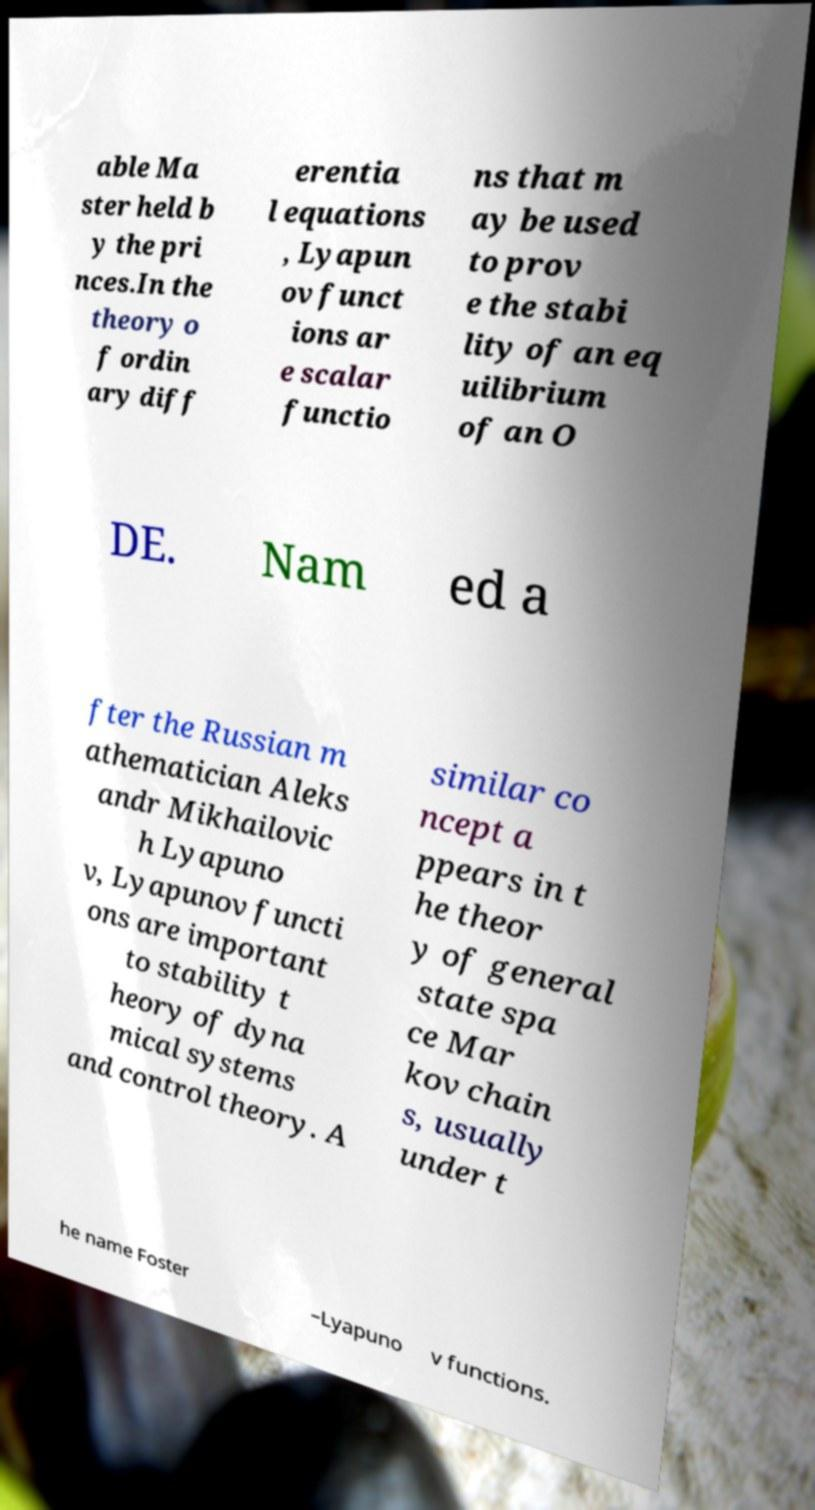What messages or text are displayed in this image? I need them in a readable, typed format. able Ma ster held b y the pri nces.In the theory o f ordin ary diff erentia l equations , Lyapun ov funct ions ar e scalar functio ns that m ay be used to prov e the stabi lity of an eq uilibrium of an O DE. Nam ed a fter the Russian m athematician Aleks andr Mikhailovic h Lyapuno v, Lyapunov functi ons are important to stability t heory of dyna mical systems and control theory. A similar co ncept a ppears in t he theor y of general state spa ce Mar kov chain s, usually under t he name Foster –Lyapuno v functions. 